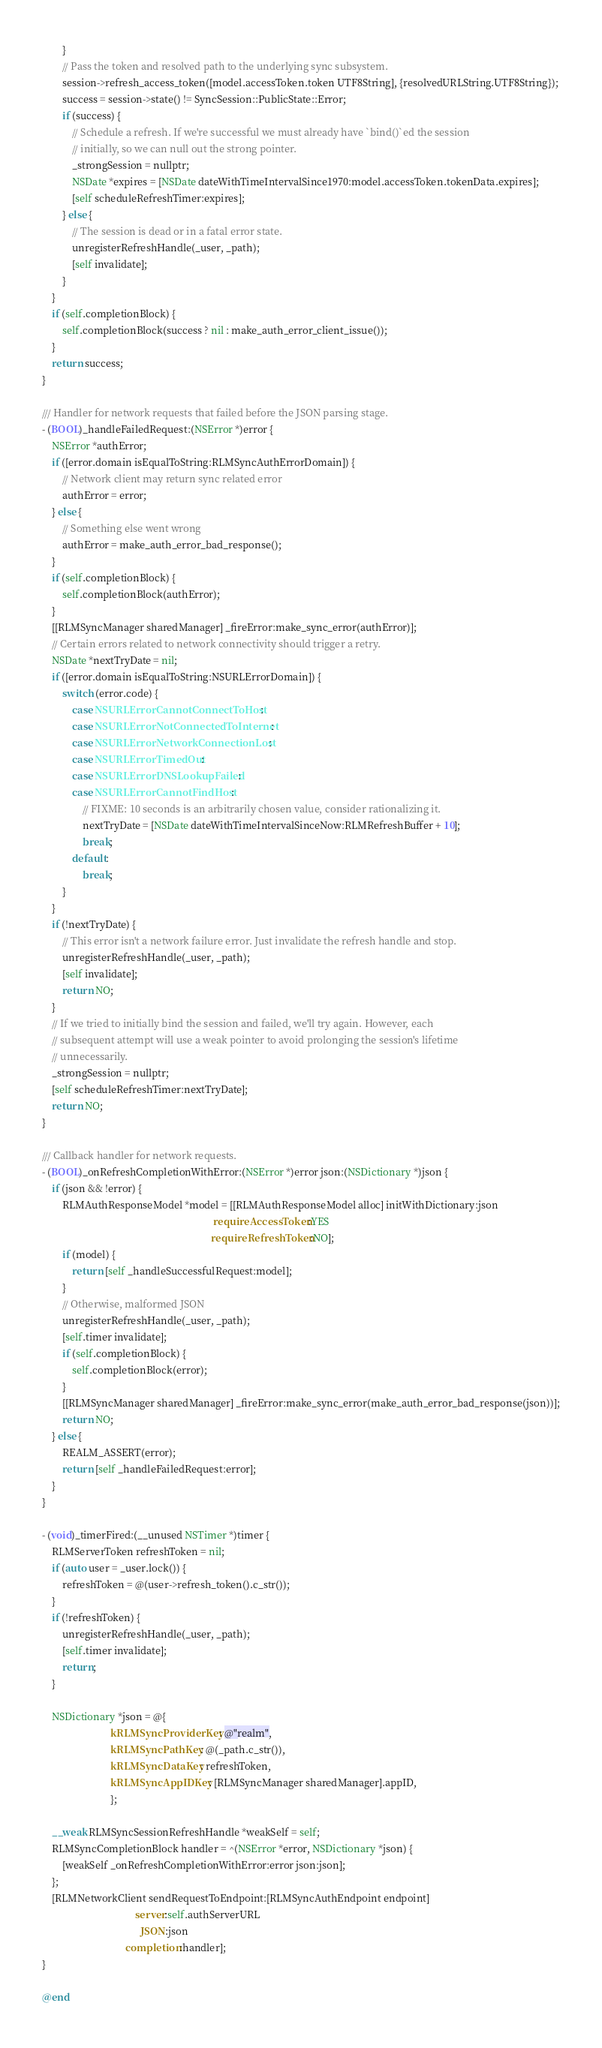<code> <loc_0><loc_0><loc_500><loc_500><_ObjectiveC_>        }
        // Pass the token and resolved path to the underlying sync subsystem.
        session->refresh_access_token([model.accessToken.token UTF8String], {resolvedURLString.UTF8String});
        success = session->state() != SyncSession::PublicState::Error;
        if (success) {
            // Schedule a refresh. If we're successful we must already have `bind()`ed the session
            // initially, so we can null out the strong pointer.
            _strongSession = nullptr;
            NSDate *expires = [NSDate dateWithTimeIntervalSince1970:model.accessToken.tokenData.expires];
            [self scheduleRefreshTimer:expires];
        } else {
            // The session is dead or in a fatal error state.
            unregisterRefreshHandle(_user, _path);
            [self invalidate];
        }
    }
    if (self.completionBlock) {
        self.completionBlock(success ? nil : make_auth_error_client_issue());
    }
    return success;
}

/// Handler for network requests that failed before the JSON parsing stage.
- (BOOL)_handleFailedRequest:(NSError *)error {
    NSError *authError;
    if ([error.domain isEqualToString:RLMSyncAuthErrorDomain]) {
        // Network client may return sync related error
        authError = error;
    } else {
        // Something else went wrong
        authError = make_auth_error_bad_response();
    }
    if (self.completionBlock) {
        self.completionBlock(authError);
    }
    [[RLMSyncManager sharedManager] _fireError:make_sync_error(authError)];
    // Certain errors related to network connectivity should trigger a retry.
    NSDate *nextTryDate = nil;
    if ([error.domain isEqualToString:NSURLErrorDomain]) {
        switch (error.code) {
            case NSURLErrorCannotConnectToHost:
            case NSURLErrorNotConnectedToInternet:
            case NSURLErrorNetworkConnectionLost:
            case NSURLErrorTimedOut:
            case NSURLErrorDNSLookupFailed:
            case NSURLErrorCannotFindHost:
                // FIXME: 10 seconds is an arbitrarily chosen value, consider rationalizing it.
                nextTryDate = [NSDate dateWithTimeIntervalSinceNow:RLMRefreshBuffer + 10];
                break;
            default:
                break;
        }
    }
    if (!nextTryDate) {
        // This error isn't a network failure error. Just invalidate the refresh handle and stop.
        unregisterRefreshHandle(_user, _path);
        [self invalidate];
        return NO;
    }
    // If we tried to initially bind the session and failed, we'll try again. However, each
    // subsequent attempt will use a weak pointer to avoid prolonging the session's lifetime
    // unnecessarily.
    _strongSession = nullptr;
    [self scheduleRefreshTimer:nextTryDate];
    return NO;
}

/// Callback handler for network requests.
- (BOOL)_onRefreshCompletionWithError:(NSError *)error json:(NSDictionary *)json {
    if (json && !error) {
        RLMAuthResponseModel *model = [[RLMAuthResponseModel alloc] initWithDictionary:json
                                                                    requireAccessToken:YES
                                                                   requireRefreshToken:NO];
        if (model) {
            return [self _handleSuccessfulRequest:model];
        }
        // Otherwise, malformed JSON
        unregisterRefreshHandle(_user, _path);
        [self.timer invalidate];
        if (self.completionBlock) {
            self.completionBlock(error);
        }
        [[RLMSyncManager sharedManager] _fireError:make_sync_error(make_auth_error_bad_response(json))];
        return NO;
    } else {
        REALM_ASSERT(error);
        return [self _handleFailedRequest:error];
    }
}

- (void)_timerFired:(__unused NSTimer *)timer {
    RLMServerToken refreshToken = nil;
    if (auto user = _user.lock()) {
        refreshToken = @(user->refresh_token().c_str());
    }
    if (!refreshToken) {
        unregisterRefreshHandle(_user, _path);
        [self.timer invalidate];
        return;
    }

    NSDictionary *json = @{
                           kRLMSyncProviderKey: @"realm",
                           kRLMSyncPathKey: @(_path.c_str()),
                           kRLMSyncDataKey: refreshToken,
                           kRLMSyncAppIDKey: [RLMSyncManager sharedManager].appID,
                           };

    __weak RLMSyncSessionRefreshHandle *weakSelf = self;
    RLMSyncCompletionBlock handler = ^(NSError *error, NSDictionary *json) {
        [weakSelf _onRefreshCompletionWithError:error json:json];
    };
    [RLMNetworkClient sendRequestToEndpoint:[RLMSyncAuthEndpoint endpoint]
                                     server:self.authServerURL
                                       JSON:json
                                 completion:handler];
}

@end
</code> 